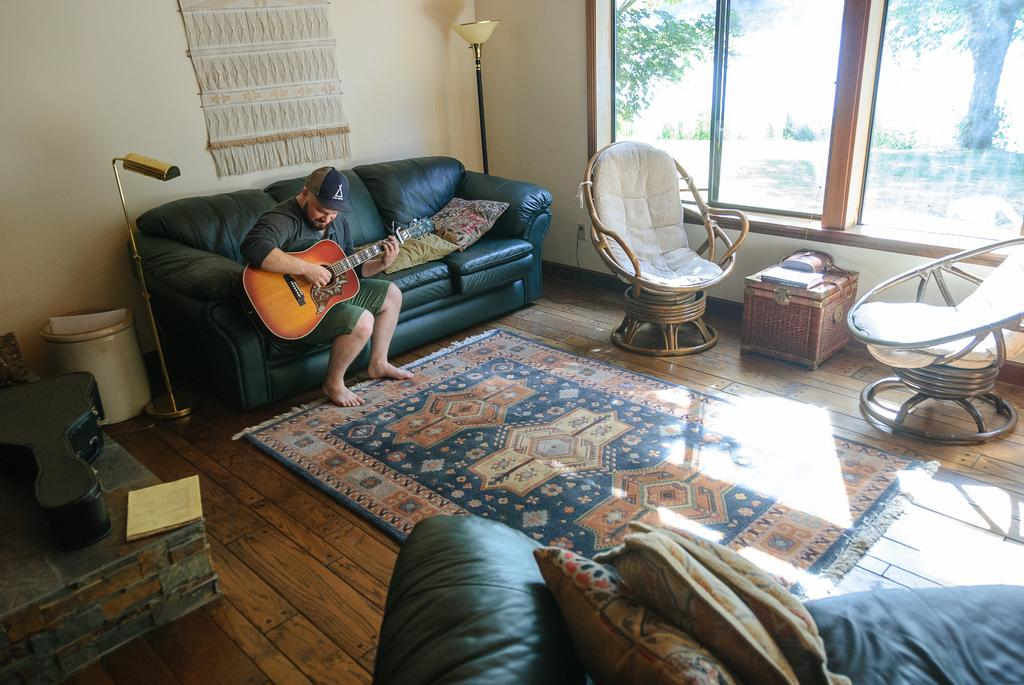Who is present in the image? There is a man in the image. What is the man doing in the image? The man is sitting on a sofa and holding a guitar. What other furniture can be seen in the image? There are chairs in the image. What type of floor covering is visible in the image? There is a floor mat in the image. How does the man show respect to the guitar in the image? The image does not show the man showing respect to the guitar; it only shows him holding it. Is the man sleeping on the sofa in the image? No, the man is sitting on the sofa, not sleeping. 